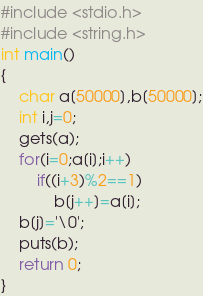Convert code to text. <code><loc_0><loc_0><loc_500><loc_500><_C_>#include <stdio.h>
#include <string.h>
int main()
{
    char a[50000],b[50000];
    int i,j=0;
    gets(a);
    for(i=0;a[i];i++)
        if((i+3)%2==1)
            b[j++]=a[i];
    b[j]='\0';
    puts(b);
    return 0;
}


</code> 